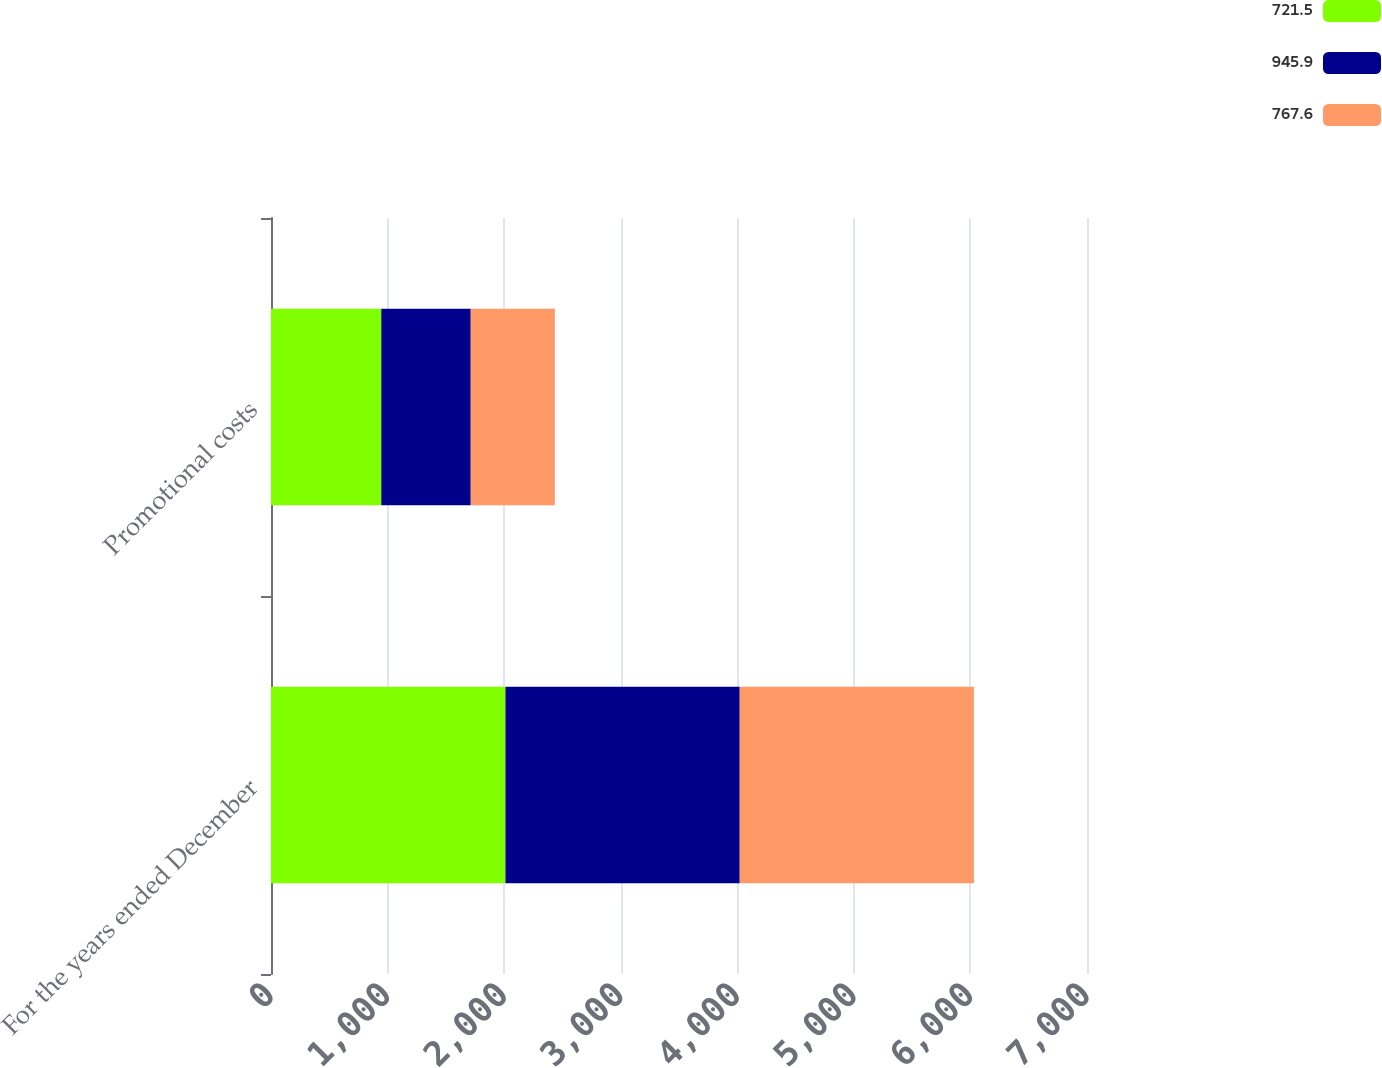<chart> <loc_0><loc_0><loc_500><loc_500><stacked_bar_chart><ecel><fcel>For the years ended December<fcel>Promotional costs<nl><fcel>721.5<fcel>2011<fcel>945.9<nl><fcel>945.9<fcel>2010<fcel>767.6<nl><fcel>767.6<fcel>2009<fcel>721.5<nl></chart> 